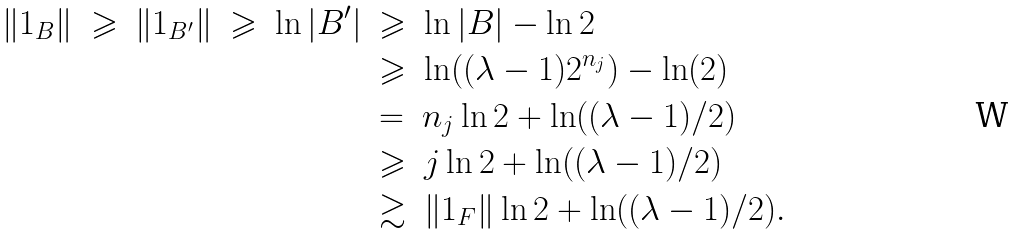<formula> <loc_0><loc_0><loc_500><loc_500>\| 1 _ { B } \| \ \geqslant \ \| 1 _ { B ^ { \prime } } \| \ \geqslant \ \ln | B ^ { \prime } | & \ \geqslant \ \ln | B | - \ln 2 \\ & \ \geqslant \ \ln ( ( \lambda - 1 ) 2 ^ { n _ { j } } ) - \ln ( 2 ) \\ & \ = \ n _ { j } \ln 2 + \ln ( ( \lambda - 1 ) / 2 ) \\ & \ \geqslant \ j \ln 2 + \ln ( ( \lambda - 1 ) / 2 ) \\ & \ \gtrsim \ \| 1 _ { F } \| \ln 2 + \ln ( ( \lambda - 1 ) / 2 ) .</formula> 